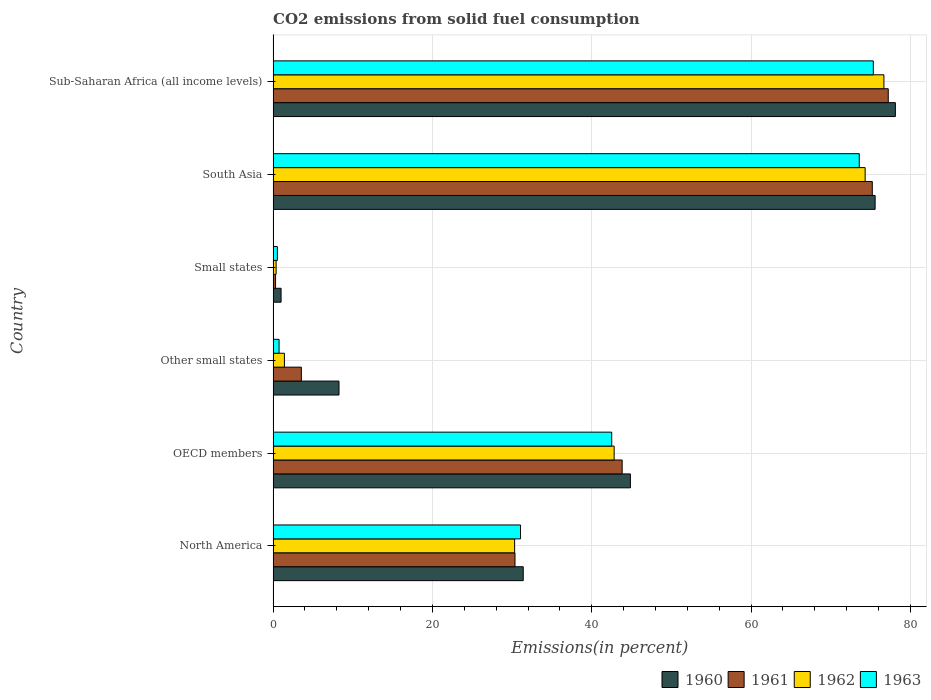How many different coloured bars are there?
Your answer should be compact. 4. Are the number of bars per tick equal to the number of legend labels?
Give a very brief answer. Yes. Are the number of bars on each tick of the Y-axis equal?
Your answer should be very brief. Yes. How many bars are there on the 1st tick from the bottom?
Keep it short and to the point. 4. What is the label of the 2nd group of bars from the top?
Ensure brevity in your answer.  South Asia. In how many cases, is the number of bars for a given country not equal to the number of legend labels?
Your answer should be very brief. 0. What is the total CO2 emitted in 1963 in OECD members?
Provide a succinct answer. 42.51. Across all countries, what is the maximum total CO2 emitted in 1963?
Your response must be concise. 75.35. Across all countries, what is the minimum total CO2 emitted in 1960?
Offer a terse response. 1. In which country was the total CO2 emitted in 1962 maximum?
Keep it short and to the point. Sub-Saharan Africa (all income levels). In which country was the total CO2 emitted in 1962 minimum?
Your answer should be compact. Small states. What is the total total CO2 emitted in 1962 in the graph?
Your answer should be compact. 225.95. What is the difference between the total CO2 emitted in 1961 in Other small states and that in Small states?
Your response must be concise. 3.24. What is the difference between the total CO2 emitted in 1963 in Other small states and the total CO2 emitted in 1961 in North America?
Provide a short and direct response. -29.62. What is the average total CO2 emitted in 1963 per country?
Provide a succinct answer. 37.3. What is the difference between the total CO2 emitted in 1960 and total CO2 emitted in 1961 in South Asia?
Your answer should be very brief. 0.36. What is the ratio of the total CO2 emitted in 1960 in Small states to that in South Asia?
Give a very brief answer. 0.01. Is the total CO2 emitted in 1963 in North America less than that in Small states?
Provide a short and direct response. No. Is the difference between the total CO2 emitted in 1960 in North America and Sub-Saharan Africa (all income levels) greater than the difference between the total CO2 emitted in 1961 in North America and Sub-Saharan Africa (all income levels)?
Ensure brevity in your answer.  Yes. What is the difference between the highest and the second highest total CO2 emitted in 1963?
Your answer should be very brief. 1.76. What is the difference between the highest and the lowest total CO2 emitted in 1963?
Keep it short and to the point. 74.82. What does the 2nd bar from the top in North America represents?
Provide a succinct answer. 1962. Is it the case that in every country, the sum of the total CO2 emitted in 1961 and total CO2 emitted in 1963 is greater than the total CO2 emitted in 1962?
Your answer should be compact. Yes. How many bars are there?
Your answer should be compact. 24. How many countries are there in the graph?
Give a very brief answer. 6. Are the values on the major ticks of X-axis written in scientific E-notation?
Give a very brief answer. No. Does the graph contain any zero values?
Make the answer very short. No. Does the graph contain grids?
Give a very brief answer. Yes. How are the legend labels stacked?
Your response must be concise. Horizontal. What is the title of the graph?
Keep it short and to the point. CO2 emissions from solid fuel consumption. What is the label or title of the X-axis?
Offer a terse response. Emissions(in percent). What is the label or title of the Y-axis?
Make the answer very short. Country. What is the Emissions(in percent) in 1960 in North America?
Provide a short and direct response. 31.4. What is the Emissions(in percent) of 1961 in North America?
Your answer should be very brief. 30.37. What is the Emissions(in percent) of 1962 in North America?
Ensure brevity in your answer.  30.32. What is the Emissions(in percent) in 1963 in North America?
Ensure brevity in your answer.  31.06. What is the Emissions(in percent) of 1960 in OECD members?
Your response must be concise. 44.86. What is the Emissions(in percent) in 1961 in OECD members?
Keep it short and to the point. 43.82. What is the Emissions(in percent) in 1962 in OECD members?
Your answer should be very brief. 42.82. What is the Emissions(in percent) in 1963 in OECD members?
Make the answer very short. 42.51. What is the Emissions(in percent) in 1960 in Other small states?
Keep it short and to the point. 8.27. What is the Emissions(in percent) of 1961 in Other small states?
Keep it short and to the point. 3.55. What is the Emissions(in percent) of 1962 in Other small states?
Your response must be concise. 1.42. What is the Emissions(in percent) in 1963 in Other small states?
Your answer should be very brief. 0.75. What is the Emissions(in percent) of 1960 in Small states?
Ensure brevity in your answer.  1. What is the Emissions(in percent) of 1961 in Small states?
Give a very brief answer. 0.31. What is the Emissions(in percent) in 1962 in Small states?
Your answer should be compact. 0.38. What is the Emissions(in percent) of 1963 in Small states?
Provide a succinct answer. 0.53. What is the Emissions(in percent) of 1960 in South Asia?
Give a very brief answer. 75.58. What is the Emissions(in percent) in 1961 in South Asia?
Your answer should be compact. 75.23. What is the Emissions(in percent) of 1962 in South Asia?
Ensure brevity in your answer.  74.33. What is the Emissions(in percent) in 1963 in South Asia?
Your answer should be compact. 73.59. What is the Emissions(in percent) of 1960 in Sub-Saharan Africa (all income levels)?
Make the answer very short. 78.13. What is the Emissions(in percent) of 1961 in Sub-Saharan Africa (all income levels)?
Provide a succinct answer. 77.23. What is the Emissions(in percent) of 1962 in Sub-Saharan Africa (all income levels)?
Keep it short and to the point. 76.69. What is the Emissions(in percent) in 1963 in Sub-Saharan Africa (all income levels)?
Your answer should be compact. 75.35. Across all countries, what is the maximum Emissions(in percent) in 1960?
Provide a short and direct response. 78.13. Across all countries, what is the maximum Emissions(in percent) in 1961?
Provide a succinct answer. 77.23. Across all countries, what is the maximum Emissions(in percent) in 1962?
Your answer should be compact. 76.69. Across all countries, what is the maximum Emissions(in percent) of 1963?
Keep it short and to the point. 75.35. Across all countries, what is the minimum Emissions(in percent) in 1960?
Your response must be concise. 1. Across all countries, what is the minimum Emissions(in percent) of 1961?
Ensure brevity in your answer.  0.31. Across all countries, what is the minimum Emissions(in percent) in 1962?
Your response must be concise. 0.38. Across all countries, what is the minimum Emissions(in percent) of 1963?
Offer a very short reply. 0.53. What is the total Emissions(in percent) in 1960 in the graph?
Ensure brevity in your answer.  239.24. What is the total Emissions(in percent) of 1961 in the graph?
Make the answer very short. 230.5. What is the total Emissions(in percent) in 1962 in the graph?
Your response must be concise. 225.95. What is the total Emissions(in percent) of 1963 in the graph?
Keep it short and to the point. 223.8. What is the difference between the Emissions(in percent) in 1960 in North America and that in OECD members?
Offer a terse response. -13.45. What is the difference between the Emissions(in percent) in 1961 in North America and that in OECD members?
Offer a very short reply. -13.45. What is the difference between the Emissions(in percent) of 1962 in North America and that in OECD members?
Provide a short and direct response. -12.49. What is the difference between the Emissions(in percent) in 1963 in North America and that in OECD members?
Provide a succinct answer. -11.45. What is the difference between the Emissions(in percent) of 1960 in North America and that in Other small states?
Your answer should be very brief. 23.13. What is the difference between the Emissions(in percent) of 1961 in North America and that in Other small states?
Offer a very short reply. 26.82. What is the difference between the Emissions(in percent) in 1962 in North America and that in Other small states?
Your response must be concise. 28.9. What is the difference between the Emissions(in percent) of 1963 in North America and that in Other small states?
Ensure brevity in your answer.  30.31. What is the difference between the Emissions(in percent) in 1960 in North America and that in Small states?
Ensure brevity in your answer.  30.4. What is the difference between the Emissions(in percent) of 1961 in North America and that in Small states?
Provide a succinct answer. 30.06. What is the difference between the Emissions(in percent) in 1962 in North America and that in Small states?
Offer a terse response. 29.95. What is the difference between the Emissions(in percent) in 1963 in North America and that in Small states?
Provide a succinct answer. 30.53. What is the difference between the Emissions(in percent) in 1960 in North America and that in South Asia?
Your response must be concise. -44.18. What is the difference between the Emissions(in percent) in 1961 in North America and that in South Asia?
Offer a very short reply. -44.86. What is the difference between the Emissions(in percent) in 1962 in North America and that in South Asia?
Your response must be concise. -44.01. What is the difference between the Emissions(in percent) in 1963 in North America and that in South Asia?
Offer a terse response. -42.53. What is the difference between the Emissions(in percent) of 1960 in North America and that in Sub-Saharan Africa (all income levels)?
Ensure brevity in your answer.  -46.72. What is the difference between the Emissions(in percent) of 1961 in North America and that in Sub-Saharan Africa (all income levels)?
Your answer should be very brief. -46.86. What is the difference between the Emissions(in percent) in 1962 in North America and that in Sub-Saharan Africa (all income levels)?
Provide a short and direct response. -46.37. What is the difference between the Emissions(in percent) in 1963 in North America and that in Sub-Saharan Africa (all income levels)?
Keep it short and to the point. -44.29. What is the difference between the Emissions(in percent) of 1960 in OECD members and that in Other small states?
Your answer should be very brief. 36.58. What is the difference between the Emissions(in percent) in 1961 in OECD members and that in Other small states?
Offer a very short reply. 40.28. What is the difference between the Emissions(in percent) in 1962 in OECD members and that in Other small states?
Provide a short and direct response. 41.4. What is the difference between the Emissions(in percent) of 1963 in OECD members and that in Other small states?
Provide a succinct answer. 41.77. What is the difference between the Emissions(in percent) of 1960 in OECD members and that in Small states?
Your answer should be compact. 43.86. What is the difference between the Emissions(in percent) of 1961 in OECD members and that in Small states?
Your answer should be compact. 43.52. What is the difference between the Emissions(in percent) in 1962 in OECD members and that in Small states?
Provide a succinct answer. 42.44. What is the difference between the Emissions(in percent) of 1963 in OECD members and that in Small states?
Your response must be concise. 41.98. What is the difference between the Emissions(in percent) in 1960 in OECD members and that in South Asia?
Offer a very short reply. -30.73. What is the difference between the Emissions(in percent) in 1961 in OECD members and that in South Asia?
Offer a terse response. -31.41. What is the difference between the Emissions(in percent) in 1962 in OECD members and that in South Asia?
Your answer should be compact. -31.51. What is the difference between the Emissions(in percent) of 1963 in OECD members and that in South Asia?
Your answer should be compact. -31.08. What is the difference between the Emissions(in percent) in 1960 in OECD members and that in Sub-Saharan Africa (all income levels)?
Give a very brief answer. -33.27. What is the difference between the Emissions(in percent) of 1961 in OECD members and that in Sub-Saharan Africa (all income levels)?
Offer a very short reply. -33.41. What is the difference between the Emissions(in percent) of 1962 in OECD members and that in Sub-Saharan Africa (all income levels)?
Your answer should be compact. -33.87. What is the difference between the Emissions(in percent) in 1963 in OECD members and that in Sub-Saharan Africa (all income levels)?
Offer a very short reply. -32.84. What is the difference between the Emissions(in percent) in 1960 in Other small states and that in Small states?
Your answer should be very brief. 7.27. What is the difference between the Emissions(in percent) of 1961 in Other small states and that in Small states?
Keep it short and to the point. 3.24. What is the difference between the Emissions(in percent) of 1962 in Other small states and that in Small states?
Ensure brevity in your answer.  1.04. What is the difference between the Emissions(in percent) in 1963 in Other small states and that in Small states?
Offer a terse response. 0.21. What is the difference between the Emissions(in percent) in 1960 in Other small states and that in South Asia?
Your answer should be very brief. -67.31. What is the difference between the Emissions(in percent) in 1961 in Other small states and that in South Asia?
Ensure brevity in your answer.  -71.68. What is the difference between the Emissions(in percent) of 1962 in Other small states and that in South Asia?
Your answer should be compact. -72.91. What is the difference between the Emissions(in percent) in 1963 in Other small states and that in South Asia?
Offer a very short reply. -72.85. What is the difference between the Emissions(in percent) of 1960 in Other small states and that in Sub-Saharan Africa (all income levels)?
Offer a very short reply. -69.86. What is the difference between the Emissions(in percent) in 1961 in Other small states and that in Sub-Saharan Africa (all income levels)?
Ensure brevity in your answer.  -73.68. What is the difference between the Emissions(in percent) of 1962 in Other small states and that in Sub-Saharan Africa (all income levels)?
Give a very brief answer. -75.27. What is the difference between the Emissions(in percent) of 1963 in Other small states and that in Sub-Saharan Africa (all income levels)?
Offer a terse response. -74.61. What is the difference between the Emissions(in percent) of 1960 in Small states and that in South Asia?
Offer a very short reply. -74.58. What is the difference between the Emissions(in percent) in 1961 in Small states and that in South Asia?
Provide a succinct answer. -74.92. What is the difference between the Emissions(in percent) of 1962 in Small states and that in South Asia?
Offer a very short reply. -73.95. What is the difference between the Emissions(in percent) of 1963 in Small states and that in South Asia?
Offer a terse response. -73.06. What is the difference between the Emissions(in percent) of 1960 in Small states and that in Sub-Saharan Africa (all income levels)?
Provide a short and direct response. -77.13. What is the difference between the Emissions(in percent) of 1961 in Small states and that in Sub-Saharan Africa (all income levels)?
Keep it short and to the point. -76.92. What is the difference between the Emissions(in percent) of 1962 in Small states and that in Sub-Saharan Africa (all income levels)?
Offer a very short reply. -76.31. What is the difference between the Emissions(in percent) of 1963 in Small states and that in Sub-Saharan Africa (all income levels)?
Keep it short and to the point. -74.82. What is the difference between the Emissions(in percent) in 1960 in South Asia and that in Sub-Saharan Africa (all income levels)?
Offer a terse response. -2.54. What is the difference between the Emissions(in percent) in 1961 in South Asia and that in Sub-Saharan Africa (all income levels)?
Your response must be concise. -2. What is the difference between the Emissions(in percent) of 1962 in South Asia and that in Sub-Saharan Africa (all income levels)?
Keep it short and to the point. -2.36. What is the difference between the Emissions(in percent) of 1963 in South Asia and that in Sub-Saharan Africa (all income levels)?
Offer a very short reply. -1.76. What is the difference between the Emissions(in percent) of 1960 in North America and the Emissions(in percent) of 1961 in OECD members?
Make the answer very short. -12.42. What is the difference between the Emissions(in percent) of 1960 in North America and the Emissions(in percent) of 1962 in OECD members?
Give a very brief answer. -11.41. What is the difference between the Emissions(in percent) in 1960 in North America and the Emissions(in percent) in 1963 in OECD members?
Offer a terse response. -11.11. What is the difference between the Emissions(in percent) of 1961 in North America and the Emissions(in percent) of 1962 in OECD members?
Ensure brevity in your answer.  -12.45. What is the difference between the Emissions(in percent) of 1961 in North America and the Emissions(in percent) of 1963 in OECD members?
Offer a very short reply. -12.14. What is the difference between the Emissions(in percent) in 1962 in North America and the Emissions(in percent) in 1963 in OECD members?
Offer a very short reply. -12.19. What is the difference between the Emissions(in percent) of 1960 in North America and the Emissions(in percent) of 1961 in Other small states?
Ensure brevity in your answer.  27.86. What is the difference between the Emissions(in percent) of 1960 in North America and the Emissions(in percent) of 1962 in Other small states?
Keep it short and to the point. 29.98. What is the difference between the Emissions(in percent) in 1960 in North America and the Emissions(in percent) in 1963 in Other small states?
Make the answer very short. 30.66. What is the difference between the Emissions(in percent) of 1961 in North America and the Emissions(in percent) of 1962 in Other small states?
Provide a succinct answer. 28.95. What is the difference between the Emissions(in percent) in 1961 in North America and the Emissions(in percent) in 1963 in Other small states?
Give a very brief answer. 29.62. What is the difference between the Emissions(in percent) of 1962 in North America and the Emissions(in percent) of 1963 in Other small states?
Offer a very short reply. 29.58. What is the difference between the Emissions(in percent) in 1960 in North America and the Emissions(in percent) in 1961 in Small states?
Offer a terse response. 31.1. What is the difference between the Emissions(in percent) in 1960 in North America and the Emissions(in percent) in 1962 in Small states?
Provide a short and direct response. 31.03. What is the difference between the Emissions(in percent) of 1960 in North America and the Emissions(in percent) of 1963 in Small states?
Your response must be concise. 30.87. What is the difference between the Emissions(in percent) of 1961 in North America and the Emissions(in percent) of 1962 in Small states?
Offer a terse response. 29.99. What is the difference between the Emissions(in percent) of 1961 in North America and the Emissions(in percent) of 1963 in Small states?
Provide a short and direct response. 29.84. What is the difference between the Emissions(in percent) of 1962 in North America and the Emissions(in percent) of 1963 in Small states?
Provide a short and direct response. 29.79. What is the difference between the Emissions(in percent) of 1960 in North America and the Emissions(in percent) of 1961 in South Asia?
Offer a terse response. -43.82. What is the difference between the Emissions(in percent) of 1960 in North America and the Emissions(in percent) of 1962 in South Asia?
Your answer should be very brief. -42.93. What is the difference between the Emissions(in percent) of 1960 in North America and the Emissions(in percent) of 1963 in South Asia?
Keep it short and to the point. -42.19. What is the difference between the Emissions(in percent) in 1961 in North America and the Emissions(in percent) in 1962 in South Asia?
Offer a very short reply. -43.96. What is the difference between the Emissions(in percent) of 1961 in North America and the Emissions(in percent) of 1963 in South Asia?
Offer a very short reply. -43.22. What is the difference between the Emissions(in percent) of 1962 in North America and the Emissions(in percent) of 1963 in South Asia?
Provide a short and direct response. -43.27. What is the difference between the Emissions(in percent) of 1960 in North America and the Emissions(in percent) of 1961 in Sub-Saharan Africa (all income levels)?
Provide a short and direct response. -45.83. What is the difference between the Emissions(in percent) in 1960 in North America and the Emissions(in percent) in 1962 in Sub-Saharan Africa (all income levels)?
Your response must be concise. -45.28. What is the difference between the Emissions(in percent) in 1960 in North America and the Emissions(in percent) in 1963 in Sub-Saharan Africa (all income levels)?
Give a very brief answer. -43.95. What is the difference between the Emissions(in percent) in 1961 in North America and the Emissions(in percent) in 1962 in Sub-Saharan Africa (all income levels)?
Give a very brief answer. -46.32. What is the difference between the Emissions(in percent) in 1961 in North America and the Emissions(in percent) in 1963 in Sub-Saharan Africa (all income levels)?
Provide a succinct answer. -44.99. What is the difference between the Emissions(in percent) in 1962 in North America and the Emissions(in percent) in 1963 in Sub-Saharan Africa (all income levels)?
Your answer should be very brief. -45.03. What is the difference between the Emissions(in percent) of 1960 in OECD members and the Emissions(in percent) of 1961 in Other small states?
Offer a very short reply. 41.31. What is the difference between the Emissions(in percent) in 1960 in OECD members and the Emissions(in percent) in 1962 in Other small states?
Your answer should be compact. 43.44. What is the difference between the Emissions(in percent) of 1960 in OECD members and the Emissions(in percent) of 1963 in Other small states?
Make the answer very short. 44.11. What is the difference between the Emissions(in percent) of 1961 in OECD members and the Emissions(in percent) of 1962 in Other small states?
Offer a very short reply. 42.4. What is the difference between the Emissions(in percent) of 1961 in OECD members and the Emissions(in percent) of 1963 in Other small states?
Keep it short and to the point. 43.08. What is the difference between the Emissions(in percent) of 1962 in OECD members and the Emissions(in percent) of 1963 in Other small states?
Provide a short and direct response. 42.07. What is the difference between the Emissions(in percent) of 1960 in OECD members and the Emissions(in percent) of 1961 in Small states?
Give a very brief answer. 44.55. What is the difference between the Emissions(in percent) in 1960 in OECD members and the Emissions(in percent) in 1962 in Small states?
Give a very brief answer. 44.48. What is the difference between the Emissions(in percent) of 1960 in OECD members and the Emissions(in percent) of 1963 in Small states?
Ensure brevity in your answer.  44.32. What is the difference between the Emissions(in percent) of 1961 in OECD members and the Emissions(in percent) of 1962 in Small states?
Provide a succinct answer. 43.45. What is the difference between the Emissions(in percent) in 1961 in OECD members and the Emissions(in percent) in 1963 in Small states?
Offer a terse response. 43.29. What is the difference between the Emissions(in percent) of 1962 in OECD members and the Emissions(in percent) of 1963 in Small states?
Make the answer very short. 42.28. What is the difference between the Emissions(in percent) in 1960 in OECD members and the Emissions(in percent) in 1961 in South Asia?
Your answer should be compact. -30.37. What is the difference between the Emissions(in percent) of 1960 in OECD members and the Emissions(in percent) of 1962 in South Asia?
Offer a terse response. -29.47. What is the difference between the Emissions(in percent) of 1960 in OECD members and the Emissions(in percent) of 1963 in South Asia?
Make the answer very short. -28.74. What is the difference between the Emissions(in percent) in 1961 in OECD members and the Emissions(in percent) in 1962 in South Asia?
Your response must be concise. -30.51. What is the difference between the Emissions(in percent) in 1961 in OECD members and the Emissions(in percent) in 1963 in South Asia?
Your response must be concise. -29.77. What is the difference between the Emissions(in percent) of 1962 in OECD members and the Emissions(in percent) of 1963 in South Asia?
Offer a very short reply. -30.78. What is the difference between the Emissions(in percent) of 1960 in OECD members and the Emissions(in percent) of 1961 in Sub-Saharan Africa (all income levels)?
Provide a succinct answer. -32.37. What is the difference between the Emissions(in percent) in 1960 in OECD members and the Emissions(in percent) in 1962 in Sub-Saharan Africa (all income levels)?
Offer a terse response. -31.83. What is the difference between the Emissions(in percent) of 1960 in OECD members and the Emissions(in percent) of 1963 in Sub-Saharan Africa (all income levels)?
Ensure brevity in your answer.  -30.5. What is the difference between the Emissions(in percent) of 1961 in OECD members and the Emissions(in percent) of 1962 in Sub-Saharan Africa (all income levels)?
Make the answer very short. -32.87. What is the difference between the Emissions(in percent) in 1961 in OECD members and the Emissions(in percent) in 1963 in Sub-Saharan Africa (all income levels)?
Your answer should be compact. -31.53. What is the difference between the Emissions(in percent) in 1962 in OECD members and the Emissions(in percent) in 1963 in Sub-Saharan Africa (all income levels)?
Give a very brief answer. -32.54. What is the difference between the Emissions(in percent) of 1960 in Other small states and the Emissions(in percent) of 1961 in Small states?
Keep it short and to the point. 7.96. What is the difference between the Emissions(in percent) in 1960 in Other small states and the Emissions(in percent) in 1962 in Small states?
Make the answer very short. 7.89. What is the difference between the Emissions(in percent) of 1960 in Other small states and the Emissions(in percent) of 1963 in Small states?
Your answer should be very brief. 7.74. What is the difference between the Emissions(in percent) of 1961 in Other small states and the Emissions(in percent) of 1962 in Small states?
Your answer should be compact. 3.17. What is the difference between the Emissions(in percent) of 1961 in Other small states and the Emissions(in percent) of 1963 in Small states?
Provide a succinct answer. 3.01. What is the difference between the Emissions(in percent) of 1962 in Other small states and the Emissions(in percent) of 1963 in Small states?
Give a very brief answer. 0.88. What is the difference between the Emissions(in percent) of 1960 in Other small states and the Emissions(in percent) of 1961 in South Asia?
Offer a terse response. -66.96. What is the difference between the Emissions(in percent) of 1960 in Other small states and the Emissions(in percent) of 1962 in South Asia?
Offer a very short reply. -66.06. What is the difference between the Emissions(in percent) of 1960 in Other small states and the Emissions(in percent) of 1963 in South Asia?
Offer a terse response. -65.32. What is the difference between the Emissions(in percent) of 1961 in Other small states and the Emissions(in percent) of 1962 in South Asia?
Give a very brief answer. -70.78. What is the difference between the Emissions(in percent) in 1961 in Other small states and the Emissions(in percent) in 1963 in South Asia?
Provide a short and direct response. -70.05. What is the difference between the Emissions(in percent) in 1962 in Other small states and the Emissions(in percent) in 1963 in South Asia?
Your answer should be compact. -72.17. What is the difference between the Emissions(in percent) of 1960 in Other small states and the Emissions(in percent) of 1961 in Sub-Saharan Africa (all income levels)?
Keep it short and to the point. -68.96. What is the difference between the Emissions(in percent) of 1960 in Other small states and the Emissions(in percent) of 1962 in Sub-Saharan Africa (all income levels)?
Keep it short and to the point. -68.42. What is the difference between the Emissions(in percent) of 1960 in Other small states and the Emissions(in percent) of 1963 in Sub-Saharan Africa (all income levels)?
Provide a short and direct response. -67.08. What is the difference between the Emissions(in percent) in 1961 in Other small states and the Emissions(in percent) in 1962 in Sub-Saharan Africa (all income levels)?
Provide a succinct answer. -73.14. What is the difference between the Emissions(in percent) of 1961 in Other small states and the Emissions(in percent) of 1963 in Sub-Saharan Africa (all income levels)?
Give a very brief answer. -71.81. What is the difference between the Emissions(in percent) of 1962 in Other small states and the Emissions(in percent) of 1963 in Sub-Saharan Africa (all income levels)?
Offer a very short reply. -73.94. What is the difference between the Emissions(in percent) in 1960 in Small states and the Emissions(in percent) in 1961 in South Asia?
Give a very brief answer. -74.23. What is the difference between the Emissions(in percent) in 1960 in Small states and the Emissions(in percent) in 1962 in South Asia?
Provide a short and direct response. -73.33. What is the difference between the Emissions(in percent) in 1960 in Small states and the Emissions(in percent) in 1963 in South Asia?
Ensure brevity in your answer.  -72.59. What is the difference between the Emissions(in percent) in 1961 in Small states and the Emissions(in percent) in 1962 in South Asia?
Your answer should be very brief. -74.02. What is the difference between the Emissions(in percent) of 1961 in Small states and the Emissions(in percent) of 1963 in South Asia?
Your answer should be very brief. -73.29. What is the difference between the Emissions(in percent) of 1962 in Small states and the Emissions(in percent) of 1963 in South Asia?
Your answer should be compact. -73.22. What is the difference between the Emissions(in percent) of 1960 in Small states and the Emissions(in percent) of 1961 in Sub-Saharan Africa (all income levels)?
Your answer should be compact. -76.23. What is the difference between the Emissions(in percent) of 1960 in Small states and the Emissions(in percent) of 1962 in Sub-Saharan Africa (all income levels)?
Your response must be concise. -75.69. What is the difference between the Emissions(in percent) of 1960 in Small states and the Emissions(in percent) of 1963 in Sub-Saharan Africa (all income levels)?
Give a very brief answer. -74.36. What is the difference between the Emissions(in percent) in 1961 in Small states and the Emissions(in percent) in 1962 in Sub-Saharan Africa (all income levels)?
Offer a terse response. -76.38. What is the difference between the Emissions(in percent) of 1961 in Small states and the Emissions(in percent) of 1963 in Sub-Saharan Africa (all income levels)?
Provide a succinct answer. -75.05. What is the difference between the Emissions(in percent) in 1962 in Small states and the Emissions(in percent) in 1963 in Sub-Saharan Africa (all income levels)?
Ensure brevity in your answer.  -74.98. What is the difference between the Emissions(in percent) in 1960 in South Asia and the Emissions(in percent) in 1961 in Sub-Saharan Africa (all income levels)?
Give a very brief answer. -1.65. What is the difference between the Emissions(in percent) in 1960 in South Asia and the Emissions(in percent) in 1962 in Sub-Saharan Africa (all income levels)?
Make the answer very short. -1.1. What is the difference between the Emissions(in percent) in 1960 in South Asia and the Emissions(in percent) in 1963 in Sub-Saharan Africa (all income levels)?
Your answer should be compact. 0.23. What is the difference between the Emissions(in percent) in 1961 in South Asia and the Emissions(in percent) in 1962 in Sub-Saharan Africa (all income levels)?
Offer a terse response. -1.46. What is the difference between the Emissions(in percent) in 1961 in South Asia and the Emissions(in percent) in 1963 in Sub-Saharan Africa (all income levels)?
Your response must be concise. -0.13. What is the difference between the Emissions(in percent) of 1962 in South Asia and the Emissions(in percent) of 1963 in Sub-Saharan Africa (all income levels)?
Keep it short and to the point. -1.03. What is the average Emissions(in percent) of 1960 per country?
Ensure brevity in your answer.  39.87. What is the average Emissions(in percent) in 1961 per country?
Provide a succinct answer. 38.42. What is the average Emissions(in percent) in 1962 per country?
Keep it short and to the point. 37.66. What is the average Emissions(in percent) in 1963 per country?
Your answer should be compact. 37.3. What is the difference between the Emissions(in percent) of 1960 and Emissions(in percent) of 1961 in North America?
Provide a succinct answer. 1.03. What is the difference between the Emissions(in percent) of 1960 and Emissions(in percent) of 1962 in North America?
Keep it short and to the point. 1.08. What is the difference between the Emissions(in percent) in 1960 and Emissions(in percent) in 1963 in North America?
Offer a terse response. 0.34. What is the difference between the Emissions(in percent) of 1961 and Emissions(in percent) of 1962 in North America?
Your response must be concise. 0.05. What is the difference between the Emissions(in percent) of 1961 and Emissions(in percent) of 1963 in North America?
Your answer should be very brief. -0.69. What is the difference between the Emissions(in percent) of 1962 and Emissions(in percent) of 1963 in North America?
Offer a terse response. -0.74. What is the difference between the Emissions(in percent) of 1960 and Emissions(in percent) of 1961 in OECD members?
Make the answer very short. 1.03. What is the difference between the Emissions(in percent) of 1960 and Emissions(in percent) of 1962 in OECD members?
Provide a short and direct response. 2.04. What is the difference between the Emissions(in percent) in 1960 and Emissions(in percent) in 1963 in OECD members?
Give a very brief answer. 2.34. What is the difference between the Emissions(in percent) of 1961 and Emissions(in percent) of 1963 in OECD members?
Provide a short and direct response. 1.31. What is the difference between the Emissions(in percent) of 1962 and Emissions(in percent) of 1963 in OECD members?
Offer a terse response. 0.3. What is the difference between the Emissions(in percent) of 1960 and Emissions(in percent) of 1961 in Other small states?
Your answer should be very brief. 4.72. What is the difference between the Emissions(in percent) of 1960 and Emissions(in percent) of 1962 in Other small states?
Give a very brief answer. 6.85. What is the difference between the Emissions(in percent) of 1960 and Emissions(in percent) of 1963 in Other small states?
Your answer should be very brief. 7.52. What is the difference between the Emissions(in percent) in 1961 and Emissions(in percent) in 1962 in Other small states?
Offer a very short reply. 2.13. What is the difference between the Emissions(in percent) of 1961 and Emissions(in percent) of 1963 in Other small states?
Your response must be concise. 2.8. What is the difference between the Emissions(in percent) in 1962 and Emissions(in percent) in 1963 in Other small states?
Your answer should be very brief. 0.67. What is the difference between the Emissions(in percent) of 1960 and Emissions(in percent) of 1961 in Small states?
Your answer should be compact. 0.69. What is the difference between the Emissions(in percent) of 1960 and Emissions(in percent) of 1962 in Small states?
Make the answer very short. 0.62. What is the difference between the Emissions(in percent) in 1960 and Emissions(in percent) in 1963 in Small states?
Your response must be concise. 0.46. What is the difference between the Emissions(in percent) in 1961 and Emissions(in percent) in 1962 in Small states?
Your answer should be very brief. -0.07. What is the difference between the Emissions(in percent) in 1961 and Emissions(in percent) in 1963 in Small states?
Ensure brevity in your answer.  -0.23. What is the difference between the Emissions(in percent) of 1962 and Emissions(in percent) of 1963 in Small states?
Make the answer very short. -0.16. What is the difference between the Emissions(in percent) of 1960 and Emissions(in percent) of 1961 in South Asia?
Your answer should be compact. 0.36. What is the difference between the Emissions(in percent) in 1960 and Emissions(in percent) in 1962 in South Asia?
Offer a very short reply. 1.25. What is the difference between the Emissions(in percent) in 1960 and Emissions(in percent) in 1963 in South Asia?
Provide a succinct answer. 1.99. What is the difference between the Emissions(in percent) of 1961 and Emissions(in percent) of 1962 in South Asia?
Ensure brevity in your answer.  0.9. What is the difference between the Emissions(in percent) of 1961 and Emissions(in percent) of 1963 in South Asia?
Give a very brief answer. 1.63. What is the difference between the Emissions(in percent) in 1962 and Emissions(in percent) in 1963 in South Asia?
Offer a very short reply. 0.74. What is the difference between the Emissions(in percent) in 1960 and Emissions(in percent) in 1961 in Sub-Saharan Africa (all income levels)?
Provide a short and direct response. 0.9. What is the difference between the Emissions(in percent) of 1960 and Emissions(in percent) of 1962 in Sub-Saharan Africa (all income levels)?
Offer a terse response. 1.44. What is the difference between the Emissions(in percent) in 1960 and Emissions(in percent) in 1963 in Sub-Saharan Africa (all income levels)?
Give a very brief answer. 2.77. What is the difference between the Emissions(in percent) of 1961 and Emissions(in percent) of 1962 in Sub-Saharan Africa (all income levels)?
Ensure brevity in your answer.  0.54. What is the difference between the Emissions(in percent) of 1961 and Emissions(in percent) of 1963 in Sub-Saharan Africa (all income levels)?
Offer a very short reply. 1.88. What is the difference between the Emissions(in percent) of 1962 and Emissions(in percent) of 1963 in Sub-Saharan Africa (all income levels)?
Ensure brevity in your answer.  1.33. What is the ratio of the Emissions(in percent) of 1960 in North America to that in OECD members?
Provide a short and direct response. 0.7. What is the ratio of the Emissions(in percent) in 1961 in North America to that in OECD members?
Provide a short and direct response. 0.69. What is the ratio of the Emissions(in percent) in 1962 in North America to that in OECD members?
Ensure brevity in your answer.  0.71. What is the ratio of the Emissions(in percent) of 1963 in North America to that in OECD members?
Ensure brevity in your answer.  0.73. What is the ratio of the Emissions(in percent) in 1960 in North America to that in Other small states?
Give a very brief answer. 3.8. What is the ratio of the Emissions(in percent) of 1961 in North America to that in Other small states?
Your answer should be compact. 8.56. What is the ratio of the Emissions(in percent) of 1962 in North America to that in Other small states?
Provide a succinct answer. 21.38. What is the ratio of the Emissions(in percent) in 1963 in North America to that in Other small states?
Your response must be concise. 41.62. What is the ratio of the Emissions(in percent) in 1960 in North America to that in Small states?
Offer a very short reply. 31.46. What is the ratio of the Emissions(in percent) of 1961 in North America to that in Small states?
Your answer should be very brief. 99.31. What is the ratio of the Emissions(in percent) of 1962 in North America to that in Small states?
Ensure brevity in your answer.  80.56. What is the ratio of the Emissions(in percent) of 1963 in North America to that in Small states?
Offer a very short reply. 58.21. What is the ratio of the Emissions(in percent) of 1960 in North America to that in South Asia?
Provide a succinct answer. 0.42. What is the ratio of the Emissions(in percent) of 1961 in North America to that in South Asia?
Your answer should be very brief. 0.4. What is the ratio of the Emissions(in percent) in 1962 in North America to that in South Asia?
Make the answer very short. 0.41. What is the ratio of the Emissions(in percent) in 1963 in North America to that in South Asia?
Provide a succinct answer. 0.42. What is the ratio of the Emissions(in percent) of 1960 in North America to that in Sub-Saharan Africa (all income levels)?
Offer a terse response. 0.4. What is the ratio of the Emissions(in percent) in 1961 in North America to that in Sub-Saharan Africa (all income levels)?
Give a very brief answer. 0.39. What is the ratio of the Emissions(in percent) in 1962 in North America to that in Sub-Saharan Africa (all income levels)?
Provide a short and direct response. 0.4. What is the ratio of the Emissions(in percent) of 1963 in North America to that in Sub-Saharan Africa (all income levels)?
Keep it short and to the point. 0.41. What is the ratio of the Emissions(in percent) in 1960 in OECD members to that in Other small states?
Your answer should be compact. 5.42. What is the ratio of the Emissions(in percent) of 1961 in OECD members to that in Other small states?
Offer a very short reply. 12.36. What is the ratio of the Emissions(in percent) of 1962 in OECD members to that in Other small states?
Keep it short and to the point. 30.19. What is the ratio of the Emissions(in percent) in 1963 in OECD members to that in Other small states?
Provide a succinct answer. 56.97. What is the ratio of the Emissions(in percent) of 1960 in OECD members to that in Small states?
Offer a terse response. 44.93. What is the ratio of the Emissions(in percent) of 1961 in OECD members to that in Small states?
Provide a succinct answer. 143.3. What is the ratio of the Emissions(in percent) in 1962 in OECD members to that in Small states?
Make the answer very short. 113.76. What is the ratio of the Emissions(in percent) in 1963 in OECD members to that in Small states?
Provide a short and direct response. 79.67. What is the ratio of the Emissions(in percent) of 1960 in OECD members to that in South Asia?
Give a very brief answer. 0.59. What is the ratio of the Emissions(in percent) in 1961 in OECD members to that in South Asia?
Your response must be concise. 0.58. What is the ratio of the Emissions(in percent) of 1962 in OECD members to that in South Asia?
Offer a terse response. 0.58. What is the ratio of the Emissions(in percent) of 1963 in OECD members to that in South Asia?
Offer a very short reply. 0.58. What is the ratio of the Emissions(in percent) of 1960 in OECD members to that in Sub-Saharan Africa (all income levels)?
Offer a terse response. 0.57. What is the ratio of the Emissions(in percent) in 1961 in OECD members to that in Sub-Saharan Africa (all income levels)?
Keep it short and to the point. 0.57. What is the ratio of the Emissions(in percent) in 1962 in OECD members to that in Sub-Saharan Africa (all income levels)?
Your answer should be very brief. 0.56. What is the ratio of the Emissions(in percent) in 1963 in OECD members to that in Sub-Saharan Africa (all income levels)?
Give a very brief answer. 0.56. What is the ratio of the Emissions(in percent) of 1960 in Other small states to that in Small states?
Offer a terse response. 8.28. What is the ratio of the Emissions(in percent) in 1961 in Other small states to that in Small states?
Provide a short and direct response. 11.6. What is the ratio of the Emissions(in percent) of 1962 in Other small states to that in Small states?
Offer a terse response. 3.77. What is the ratio of the Emissions(in percent) in 1963 in Other small states to that in Small states?
Offer a terse response. 1.4. What is the ratio of the Emissions(in percent) of 1960 in Other small states to that in South Asia?
Your answer should be compact. 0.11. What is the ratio of the Emissions(in percent) of 1961 in Other small states to that in South Asia?
Provide a succinct answer. 0.05. What is the ratio of the Emissions(in percent) in 1962 in Other small states to that in South Asia?
Your answer should be compact. 0.02. What is the ratio of the Emissions(in percent) of 1963 in Other small states to that in South Asia?
Your answer should be compact. 0.01. What is the ratio of the Emissions(in percent) of 1960 in Other small states to that in Sub-Saharan Africa (all income levels)?
Make the answer very short. 0.11. What is the ratio of the Emissions(in percent) in 1961 in Other small states to that in Sub-Saharan Africa (all income levels)?
Offer a very short reply. 0.05. What is the ratio of the Emissions(in percent) of 1962 in Other small states to that in Sub-Saharan Africa (all income levels)?
Your answer should be compact. 0.02. What is the ratio of the Emissions(in percent) in 1963 in Other small states to that in Sub-Saharan Africa (all income levels)?
Make the answer very short. 0.01. What is the ratio of the Emissions(in percent) of 1960 in Small states to that in South Asia?
Provide a succinct answer. 0.01. What is the ratio of the Emissions(in percent) in 1961 in Small states to that in South Asia?
Ensure brevity in your answer.  0. What is the ratio of the Emissions(in percent) of 1962 in Small states to that in South Asia?
Provide a succinct answer. 0.01. What is the ratio of the Emissions(in percent) of 1963 in Small states to that in South Asia?
Give a very brief answer. 0.01. What is the ratio of the Emissions(in percent) in 1960 in Small states to that in Sub-Saharan Africa (all income levels)?
Provide a succinct answer. 0.01. What is the ratio of the Emissions(in percent) of 1961 in Small states to that in Sub-Saharan Africa (all income levels)?
Ensure brevity in your answer.  0. What is the ratio of the Emissions(in percent) of 1962 in Small states to that in Sub-Saharan Africa (all income levels)?
Provide a succinct answer. 0. What is the ratio of the Emissions(in percent) of 1963 in Small states to that in Sub-Saharan Africa (all income levels)?
Your response must be concise. 0.01. What is the ratio of the Emissions(in percent) in 1960 in South Asia to that in Sub-Saharan Africa (all income levels)?
Give a very brief answer. 0.97. What is the ratio of the Emissions(in percent) of 1961 in South Asia to that in Sub-Saharan Africa (all income levels)?
Your answer should be compact. 0.97. What is the ratio of the Emissions(in percent) of 1962 in South Asia to that in Sub-Saharan Africa (all income levels)?
Your answer should be very brief. 0.97. What is the ratio of the Emissions(in percent) of 1963 in South Asia to that in Sub-Saharan Africa (all income levels)?
Your answer should be compact. 0.98. What is the difference between the highest and the second highest Emissions(in percent) in 1960?
Provide a short and direct response. 2.54. What is the difference between the highest and the second highest Emissions(in percent) in 1961?
Your response must be concise. 2. What is the difference between the highest and the second highest Emissions(in percent) of 1962?
Keep it short and to the point. 2.36. What is the difference between the highest and the second highest Emissions(in percent) in 1963?
Provide a succinct answer. 1.76. What is the difference between the highest and the lowest Emissions(in percent) of 1960?
Your answer should be compact. 77.13. What is the difference between the highest and the lowest Emissions(in percent) in 1961?
Your answer should be compact. 76.92. What is the difference between the highest and the lowest Emissions(in percent) of 1962?
Ensure brevity in your answer.  76.31. What is the difference between the highest and the lowest Emissions(in percent) in 1963?
Provide a short and direct response. 74.82. 